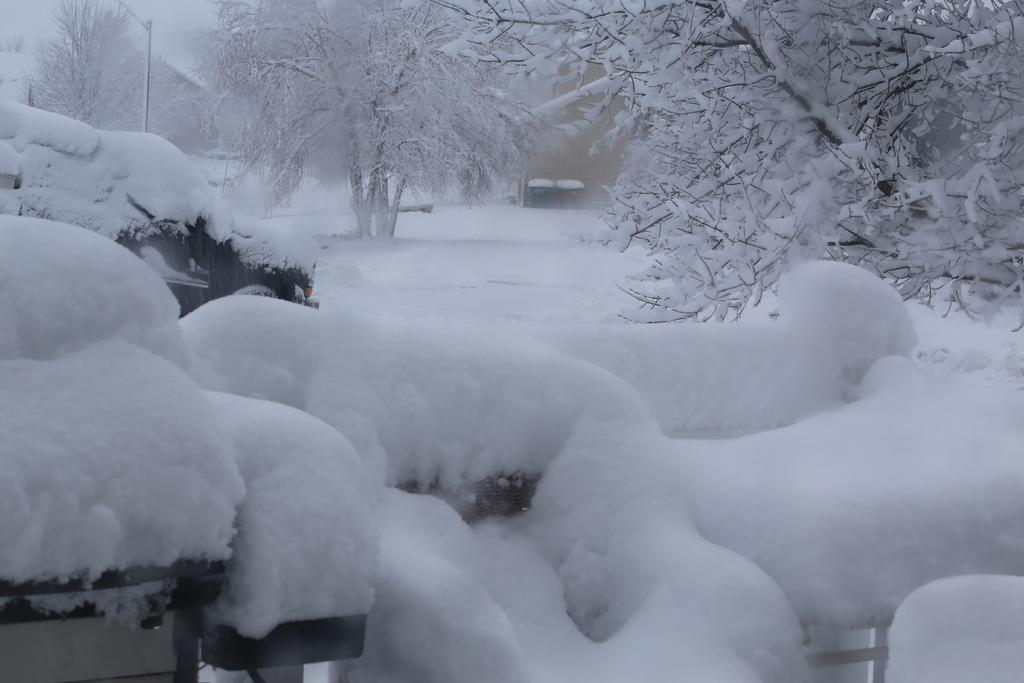What is the predominant feature of the image? There is snow everywhere in the image. What can be seen on the left side of the image? There are vehicles on the left side of the image. What is located on the right side of the image? There are trees on the right side of the image. What structures are visible in the background of the image? There are houses and a pole in the background of the image. What type of vegetation is present in the background of the image? There are trees in the background of the image. What color is the rock in the image? There is no rock present in the image. 